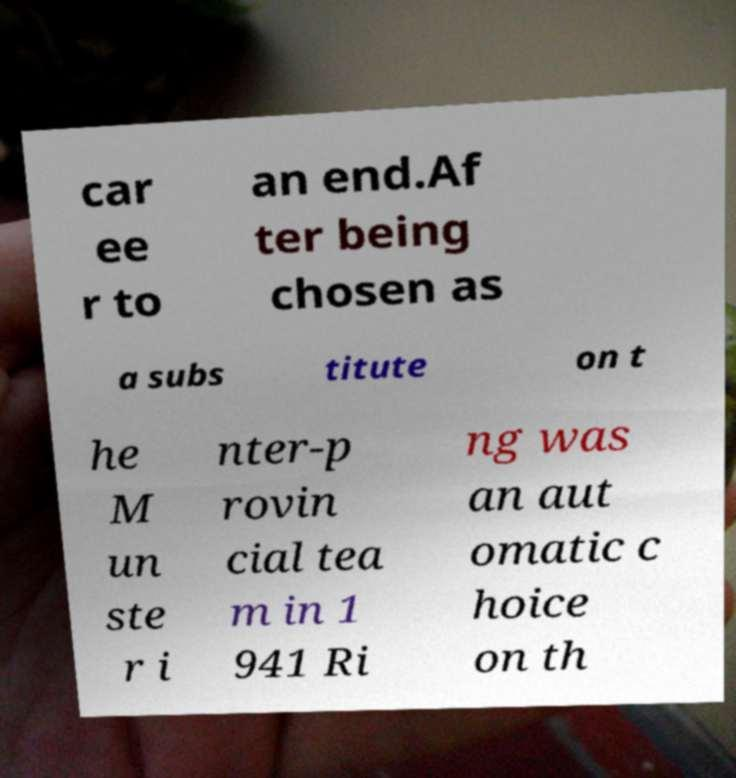There's text embedded in this image that I need extracted. Can you transcribe it verbatim? car ee r to an end.Af ter being chosen as a subs titute on t he M un ste r i nter-p rovin cial tea m in 1 941 Ri ng was an aut omatic c hoice on th 